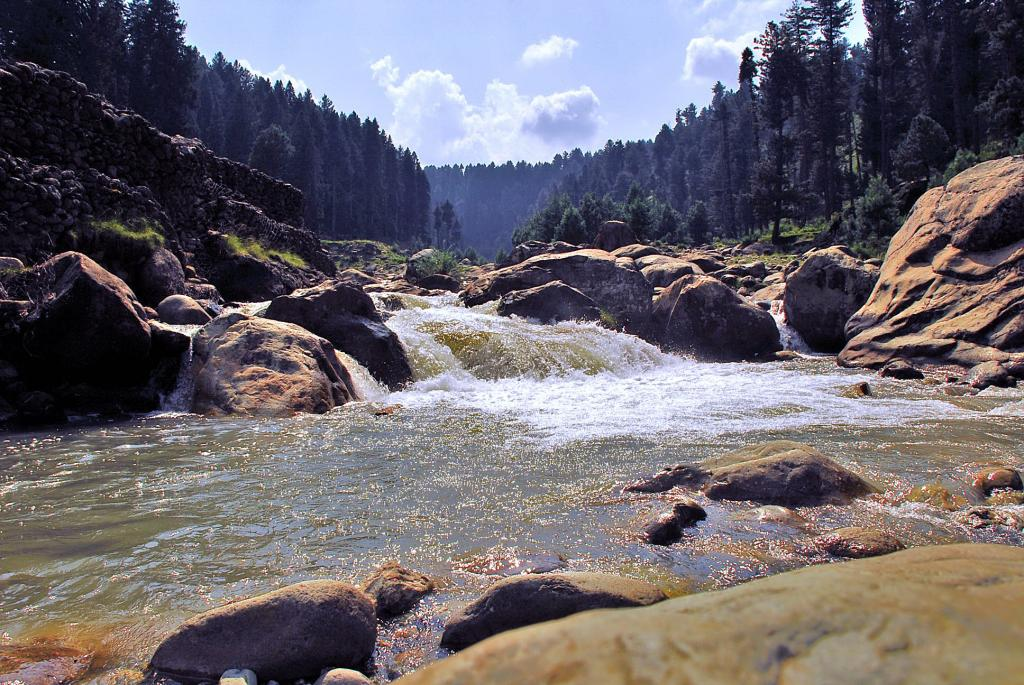What is the color of the sky in the image? The sky in the image is blue and slightly cloudy. What type of natural features can be seen in the image? There are many rocks and trees in the image. What is the presence of water in the image? There is the flow of water in the image. What type of toys can be seen floating in the water in the image? There are no toys present in the image; it features rocks, trees, and flowing water. What type of nut is growing on the trees in the image? There is no nut mentioned or visible in the image; it only features trees and rocks. 